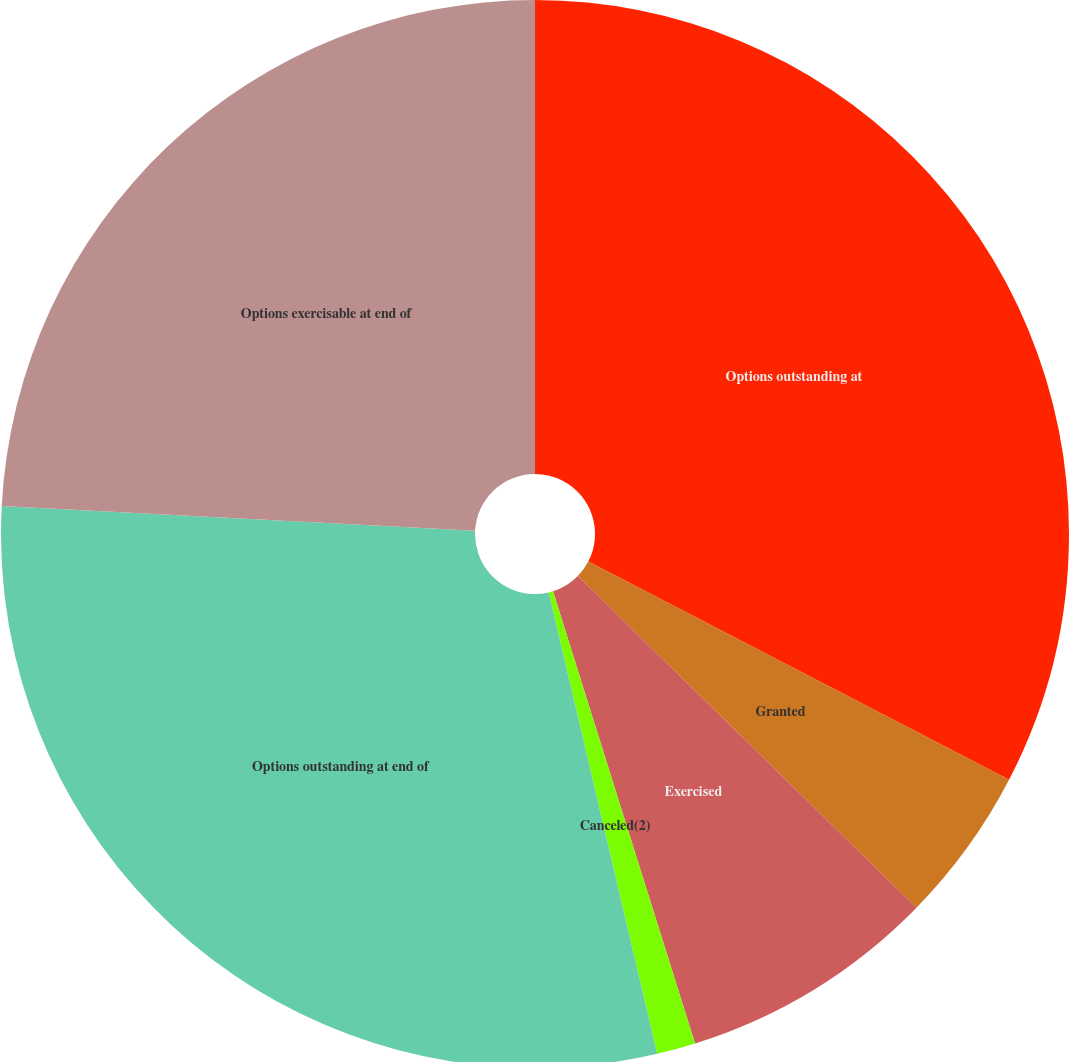<chart> <loc_0><loc_0><loc_500><loc_500><pie_chart><fcel>Options outstanding at<fcel>Granted<fcel>Exercised<fcel>Canceled(2)<fcel>Options outstanding at end of<fcel>Options exercisable at end of<nl><fcel>32.61%<fcel>4.72%<fcel>7.82%<fcel>1.17%<fcel>29.51%<fcel>24.16%<nl></chart> 